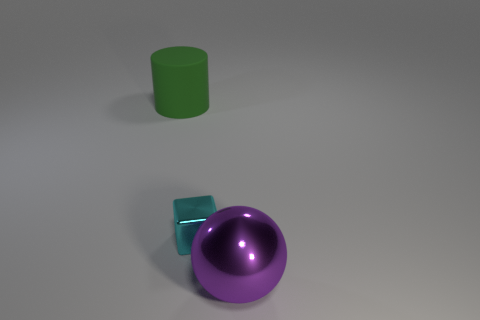How many cyan objects are metallic balls or big cylinders?
Give a very brief answer. 0. Is the small cyan cube made of the same material as the large object that is on the left side of the shiny sphere?
Offer a very short reply. No. Is the number of big green matte objects to the left of the big ball the same as the number of matte objects that are on the right side of the cyan metallic cube?
Your answer should be compact. No. Does the purple metallic object have the same size as the object that is on the left side of the small cyan shiny object?
Your answer should be compact. Yes. Are there more cyan metal blocks left of the cyan shiny object than large brown objects?
Your answer should be very brief. No. How many purple balls have the same size as the cyan metal cube?
Offer a terse response. 0. Do the thing left of the tiny shiny thing and the thing that is in front of the cyan shiny object have the same size?
Make the answer very short. Yes. Is the number of metal cubes that are to the left of the large rubber cylinder greater than the number of large metal spheres behind the tiny cyan shiny thing?
Give a very brief answer. No. How many other shiny things have the same shape as the cyan metal thing?
Your answer should be compact. 0. What material is the green object that is the same size as the metal ball?
Ensure brevity in your answer.  Rubber. 